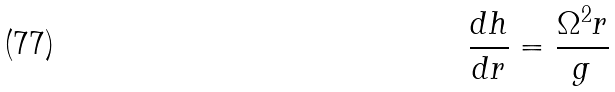<formula> <loc_0><loc_0><loc_500><loc_500>\frac { d h } { d r } = \frac { \Omega ^ { 2 } r } { g }</formula> 